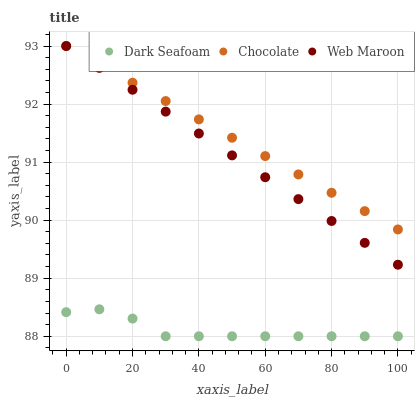Does Dark Seafoam have the minimum area under the curve?
Answer yes or no. Yes. Does Chocolate have the maximum area under the curve?
Answer yes or no. Yes. Does Web Maroon have the minimum area under the curve?
Answer yes or no. No. Does Web Maroon have the maximum area under the curve?
Answer yes or no. No. Is Web Maroon the smoothest?
Answer yes or no. Yes. Is Dark Seafoam the roughest?
Answer yes or no. Yes. Is Chocolate the smoothest?
Answer yes or no. No. Is Chocolate the roughest?
Answer yes or no. No. Does Dark Seafoam have the lowest value?
Answer yes or no. Yes. Does Web Maroon have the lowest value?
Answer yes or no. No. Does Chocolate have the highest value?
Answer yes or no. Yes. Is Dark Seafoam less than Chocolate?
Answer yes or no. Yes. Is Chocolate greater than Dark Seafoam?
Answer yes or no. Yes. Does Chocolate intersect Web Maroon?
Answer yes or no. Yes. Is Chocolate less than Web Maroon?
Answer yes or no. No. Is Chocolate greater than Web Maroon?
Answer yes or no. No. Does Dark Seafoam intersect Chocolate?
Answer yes or no. No. 